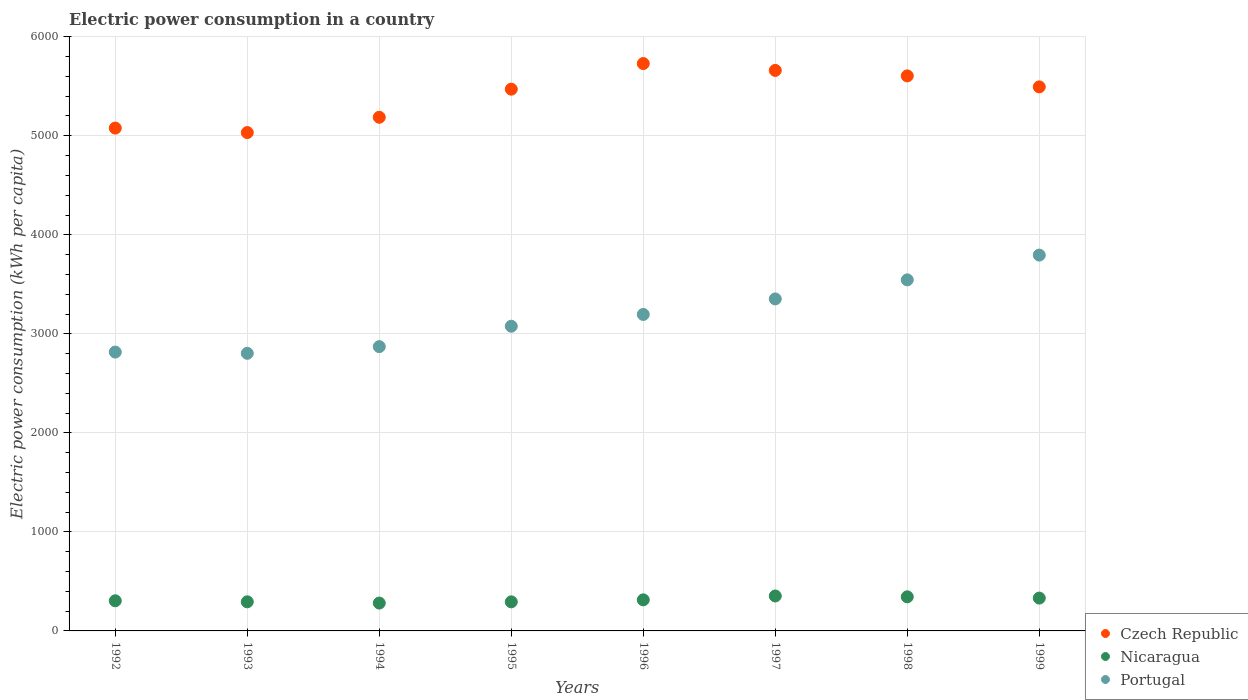How many different coloured dotlines are there?
Provide a succinct answer. 3. What is the electric power consumption in in Portugal in 1997?
Make the answer very short. 3352.47. Across all years, what is the maximum electric power consumption in in Portugal?
Your answer should be very brief. 3795.23. Across all years, what is the minimum electric power consumption in in Nicaragua?
Offer a terse response. 281.15. In which year was the electric power consumption in in Nicaragua maximum?
Your answer should be very brief. 1997. What is the total electric power consumption in in Nicaragua in the graph?
Make the answer very short. 2515.47. What is the difference between the electric power consumption in in Portugal in 1993 and that in 1994?
Your response must be concise. -67.63. What is the difference between the electric power consumption in in Nicaragua in 1998 and the electric power consumption in in Portugal in 1995?
Keep it short and to the point. -2732.47. What is the average electric power consumption in in Portugal per year?
Offer a very short reply. 3181.92. In the year 1992, what is the difference between the electric power consumption in in Nicaragua and electric power consumption in in Portugal?
Offer a terse response. -2511.58. In how many years, is the electric power consumption in in Czech Republic greater than 2000 kWh per capita?
Your answer should be compact. 8. What is the ratio of the electric power consumption in in Czech Republic in 1995 to that in 1999?
Offer a very short reply. 1. Is the difference between the electric power consumption in in Nicaragua in 1992 and 1997 greater than the difference between the electric power consumption in in Portugal in 1992 and 1997?
Your answer should be very brief. Yes. What is the difference between the highest and the second highest electric power consumption in in Portugal?
Your answer should be very brief. 250.22. What is the difference between the highest and the lowest electric power consumption in in Czech Republic?
Offer a very short reply. 696.98. Is the sum of the electric power consumption in in Portugal in 1995 and 1998 greater than the maximum electric power consumption in in Czech Republic across all years?
Ensure brevity in your answer.  Yes. Does the electric power consumption in in Portugal monotonically increase over the years?
Keep it short and to the point. No. Is the electric power consumption in in Portugal strictly greater than the electric power consumption in in Nicaragua over the years?
Your response must be concise. Yes. Is the electric power consumption in in Czech Republic strictly less than the electric power consumption in in Portugal over the years?
Make the answer very short. No. How many years are there in the graph?
Offer a terse response. 8. Does the graph contain any zero values?
Make the answer very short. No. How many legend labels are there?
Offer a terse response. 3. What is the title of the graph?
Make the answer very short. Electric power consumption in a country. What is the label or title of the X-axis?
Provide a succinct answer. Years. What is the label or title of the Y-axis?
Your answer should be very brief. Electric power consumption (kWh per capita). What is the Electric power consumption (kWh per capita) in Czech Republic in 1992?
Offer a terse response. 5077.66. What is the Electric power consumption (kWh per capita) in Nicaragua in 1992?
Your response must be concise. 304.3. What is the Electric power consumption (kWh per capita) in Portugal in 1992?
Your answer should be compact. 2815.88. What is the Electric power consumption (kWh per capita) in Czech Republic in 1993?
Your response must be concise. 5032.4. What is the Electric power consumption (kWh per capita) in Nicaragua in 1993?
Ensure brevity in your answer.  293.91. What is the Electric power consumption (kWh per capita) in Portugal in 1993?
Provide a short and direct response. 2803.2. What is the Electric power consumption (kWh per capita) of Czech Republic in 1994?
Your answer should be very brief. 5186.97. What is the Electric power consumption (kWh per capita) of Nicaragua in 1994?
Offer a very short reply. 281.15. What is the Electric power consumption (kWh per capita) in Portugal in 1994?
Offer a terse response. 2870.83. What is the Electric power consumption (kWh per capita) in Czech Republic in 1995?
Provide a short and direct response. 5470.67. What is the Electric power consumption (kWh per capita) in Nicaragua in 1995?
Give a very brief answer. 293.57. What is the Electric power consumption (kWh per capita) in Portugal in 1995?
Ensure brevity in your answer.  3076.85. What is the Electric power consumption (kWh per capita) of Czech Republic in 1996?
Keep it short and to the point. 5729.39. What is the Electric power consumption (kWh per capita) in Nicaragua in 1996?
Your answer should be compact. 313.78. What is the Electric power consumption (kWh per capita) of Portugal in 1996?
Your answer should be compact. 3195.86. What is the Electric power consumption (kWh per capita) of Czech Republic in 1997?
Offer a terse response. 5660.06. What is the Electric power consumption (kWh per capita) in Nicaragua in 1997?
Give a very brief answer. 352.86. What is the Electric power consumption (kWh per capita) in Portugal in 1997?
Ensure brevity in your answer.  3352.47. What is the Electric power consumption (kWh per capita) of Czech Republic in 1998?
Give a very brief answer. 5604.81. What is the Electric power consumption (kWh per capita) of Nicaragua in 1998?
Offer a very short reply. 344.38. What is the Electric power consumption (kWh per capita) in Portugal in 1998?
Make the answer very short. 3545.01. What is the Electric power consumption (kWh per capita) in Czech Republic in 1999?
Provide a succinct answer. 5493.85. What is the Electric power consumption (kWh per capita) of Nicaragua in 1999?
Your answer should be very brief. 331.54. What is the Electric power consumption (kWh per capita) of Portugal in 1999?
Your answer should be compact. 3795.23. Across all years, what is the maximum Electric power consumption (kWh per capita) in Czech Republic?
Your answer should be compact. 5729.39. Across all years, what is the maximum Electric power consumption (kWh per capita) in Nicaragua?
Keep it short and to the point. 352.86. Across all years, what is the maximum Electric power consumption (kWh per capita) of Portugal?
Your answer should be compact. 3795.23. Across all years, what is the minimum Electric power consumption (kWh per capita) of Czech Republic?
Keep it short and to the point. 5032.4. Across all years, what is the minimum Electric power consumption (kWh per capita) of Nicaragua?
Give a very brief answer. 281.15. Across all years, what is the minimum Electric power consumption (kWh per capita) in Portugal?
Your answer should be compact. 2803.2. What is the total Electric power consumption (kWh per capita) of Czech Republic in the graph?
Your answer should be very brief. 4.33e+04. What is the total Electric power consumption (kWh per capita) in Nicaragua in the graph?
Offer a terse response. 2515.47. What is the total Electric power consumption (kWh per capita) in Portugal in the graph?
Make the answer very short. 2.55e+04. What is the difference between the Electric power consumption (kWh per capita) in Czech Republic in 1992 and that in 1993?
Provide a short and direct response. 45.26. What is the difference between the Electric power consumption (kWh per capita) of Nicaragua in 1992 and that in 1993?
Provide a short and direct response. 10.39. What is the difference between the Electric power consumption (kWh per capita) in Portugal in 1992 and that in 1993?
Provide a succinct answer. 12.67. What is the difference between the Electric power consumption (kWh per capita) of Czech Republic in 1992 and that in 1994?
Ensure brevity in your answer.  -109.31. What is the difference between the Electric power consumption (kWh per capita) of Nicaragua in 1992 and that in 1994?
Your answer should be very brief. 23.15. What is the difference between the Electric power consumption (kWh per capita) of Portugal in 1992 and that in 1994?
Your answer should be compact. -54.96. What is the difference between the Electric power consumption (kWh per capita) of Czech Republic in 1992 and that in 1995?
Provide a succinct answer. -393.01. What is the difference between the Electric power consumption (kWh per capita) of Nicaragua in 1992 and that in 1995?
Offer a terse response. 10.73. What is the difference between the Electric power consumption (kWh per capita) in Portugal in 1992 and that in 1995?
Keep it short and to the point. -260.97. What is the difference between the Electric power consumption (kWh per capita) of Czech Republic in 1992 and that in 1996?
Give a very brief answer. -651.73. What is the difference between the Electric power consumption (kWh per capita) in Nicaragua in 1992 and that in 1996?
Offer a terse response. -9.48. What is the difference between the Electric power consumption (kWh per capita) in Portugal in 1992 and that in 1996?
Offer a terse response. -379.99. What is the difference between the Electric power consumption (kWh per capita) of Czech Republic in 1992 and that in 1997?
Make the answer very short. -582.4. What is the difference between the Electric power consumption (kWh per capita) of Nicaragua in 1992 and that in 1997?
Keep it short and to the point. -48.56. What is the difference between the Electric power consumption (kWh per capita) in Portugal in 1992 and that in 1997?
Give a very brief answer. -536.59. What is the difference between the Electric power consumption (kWh per capita) of Czech Republic in 1992 and that in 1998?
Offer a very short reply. -527.15. What is the difference between the Electric power consumption (kWh per capita) in Nicaragua in 1992 and that in 1998?
Ensure brevity in your answer.  -40.08. What is the difference between the Electric power consumption (kWh per capita) in Portugal in 1992 and that in 1998?
Provide a short and direct response. -729.13. What is the difference between the Electric power consumption (kWh per capita) of Czech Republic in 1992 and that in 1999?
Make the answer very short. -416.19. What is the difference between the Electric power consumption (kWh per capita) of Nicaragua in 1992 and that in 1999?
Your answer should be very brief. -27.24. What is the difference between the Electric power consumption (kWh per capita) of Portugal in 1992 and that in 1999?
Offer a terse response. -979.35. What is the difference between the Electric power consumption (kWh per capita) of Czech Republic in 1993 and that in 1994?
Provide a short and direct response. -154.57. What is the difference between the Electric power consumption (kWh per capita) in Nicaragua in 1993 and that in 1994?
Ensure brevity in your answer.  12.76. What is the difference between the Electric power consumption (kWh per capita) in Portugal in 1993 and that in 1994?
Your answer should be compact. -67.63. What is the difference between the Electric power consumption (kWh per capita) in Czech Republic in 1993 and that in 1995?
Your answer should be compact. -438.27. What is the difference between the Electric power consumption (kWh per capita) of Nicaragua in 1993 and that in 1995?
Your answer should be very brief. 0.34. What is the difference between the Electric power consumption (kWh per capita) in Portugal in 1993 and that in 1995?
Your answer should be very brief. -273.64. What is the difference between the Electric power consumption (kWh per capita) in Czech Republic in 1993 and that in 1996?
Offer a very short reply. -696.98. What is the difference between the Electric power consumption (kWh per capita) of Nicaragua in 1993 and that in 1996?
Offer a terse response. -19.87. What is the difference between the Electric power consumption (kWh per capita) in Portugal in 1993 and that in 1996?
Provide a short and direct response. -392.66. What is the difference between the Electric power consumption (kWh per capita) of Czech Republic in 1993 and that in 1997?
Offer a very short reply. -627.66. What is the difference between the Electric power consumption (kWh per capita) in Nicaragua in 1993 and that in 1997?
Give a very brief answer. -58.95. What is the difference between the Electric power consumption (kWh per capita) in Portugal in 1993 and that in 1997?
Your answer should be compact. -549.26. What is the difference between the Electric power consumption (kWh per capita) in Czech Republic in 1993 and that in 1998?
Provide a short and direct response. -572.41. What is the difference between the Electric power consumption (kWh per capita) of Nicaragua in 1993 and that in 1998?
Keep it short and to the point. -50.47. What is the difference between the Electric power consumption (kWh per capita) of Portugal in 1993 and that in 1998?
Ensure brevity in your answer.  -741.81. What is the difference between the Electric power consumption (kWh per capita) in Czech Republic in 1993 and that in 1999?
Make the answer very short. -461.45. What is the difference between the Electric power consumption (kWh per capita) of Nicaragua in 1993 and that in 1999?
Provide a succinct answer. -37.63. What is the difference between the Electric power consumption (kWh per capita) of Portugal in 1993 and that in 1999?
Your answer should be compact. -992.03. What is the difference between the Electric power consumption (kWh per capita) in Czech Republic in 1994 and that in 1995?
Offer a terse response. -283.7. What is the difference between the Electric power consumption (kWh per capita) in Nicaragua in 1994 and that in 1995?
Make the answer very short. -12.42. What is the difference between the Electric power consumption (kWh per capita) of Portugal in 1994 and that in 1995?
Your answer should be compact. -206.01. What is the difference between the Electric power consumption (kWh per capita) of Czech Republic in 1994 and that in 1996?
Keep it short and to the point. -542.42. What is the difference between the Electric power consumption (kWh per capita) in Nicaragua in 1994 and that in 1996?
Provide a short and direct response. -32.63. What is the difference between the Electric power consumption (kWh per capita) of Portugal in 1994 and that in 1996?
Your response must be concise. -325.03. What is the difference between the Electric power consumption (kWh per capita) of Czech Republic in 1994 and that in 1997?
Offer a terse response. -473.09. What is the difference between the Electric power consumption (kWh per capita) of Nicaragua in 1994 and that in 1997?
Offer a terse response. -71.71. What is the difference between the Electric power consumption (kWh per capita) in Portugal in 1994 and that in 1997?
Ensure brevity in your answer.  -481.63. What is the difference between the Electric power consumption (kWh per capita) of Czech Republic in 1994 and that in 1998?
Keep it short and to the point. -417.84. What is the difference between the Electric power consumption (kWh per capita) of Nicaragua in 1994 and that in 1998?
Your answer should be compact. -63.23. What is the difference between the Electric power consumption (kWh per capita) in Portugal in 1994 and that in 1998?
Your answer should be very brief. -674.18. What is the difference between the Electric power consumption (kWh per capita) in Czech Republic in 1994 and that in 1999?
Provide a succinct answer. -306.88. What is the difference between the Electric power consumption (kWh per capita) of Nicaragua in 1994 and that in 1999?
Make the answer very short. -50.39. What is the difference between the Electric power consumption (kWh per capita) in Portugal in 1994 and that in 1999?
Make the answer very short. -924.4. What is the difference between the Electric power consumption (kWh per capita) in Czech Republic in 1995 and that in 1996?
Your answer should be compact. -258.72. What is the difference between the Electric power consumption (kWh per capita) in Nicaragua in 1995 and that in 1996?
Your answer should be very brief. -20.21. What is the difference between the Electric power consumption (kWh per capita) of Portugal in 1995 and that in 1996?
Your answer should be very brief. -119.02. What is the difference between the Electric power consumption (kWh per capita) of Czech Republic in 1995 and that in 1997?
Give a very brief answer. -189.39. What is the difference between the Electric power consumption (kWh per capita) of Nicaragua in 1995 and that in 1997?
Provide a short and direct response. -59.29. What is the difference between the Electric power consumption (kWh per capita) of Portugal in 1995 and that in 1997?
Ensure brevity in your answer.  -275.62. What is the difference between the Electric power consumption (kWh per capita) in Czech Republic in 1995 and that in 1998?
Give a very brief answer. -134.14. What is the difference between the Electric power consumption (kWh per capita) in Nicaragua in 1995 and that in 1998?
Provide a short and direct response. -50.81. What is the difference between the Electric power consumption (kWh per capita) of Portugal in 1995 and that in 1998?
Make the answer very short. -468.16. What is the difference between the Electric power consumption (kWh per capita) of Czech Republic in 1995 and that in 1999?
Provide a short and direct response. -23.18. What is the difference between the Electric power consumption (kWh per capita) in Nicaragua in 1995 and that in 1999?
Your response must be concise. -37.97. What is the difference between the Electric power consumption (kWh per capita) of Portugal in 1995 and that in 1999?
Keep it short and to the point. -718.38. What is the difference between the Electric power consumption (kWh per capita) of Czech Republic in 1996 and that in 1997?
Give a very brief answer. 69.33. What is the difference between the Electric power consumption (kWh per capita) of Nicaragua in 1996 and that in 1997?
Your response must be concise. -39.08. What is the difference between the Electric power consumption (kWh per capita) of Portugal in 1996 and that in 1997?
Keep it short and to the point. -156.6. What is the difference between the Electric power consumption (kWh per capita) in Czech Republic in 1996 and that in 1998?
Keep it short and to the point. 124.58. What is the difference between the Electric power consumption (kWh per capita) in Nicaragua in 1996 and that in 1998?
Your answer should be very brief. -30.6. What is the difference between the Electric power consumption (kWh per capita) of Portugal in 1996 and that in 1998?
Keep it short and to the point. -349.15. What is the difference between the Electric power consumption (kWh per capita) in Czech Republic in 1996 and that in 1999?
Give a very brief answer. 235.53. What is the difference between the Electric power consumption (kWh per capita) in Nicaragua in 1996 and that in 1999?
Make the answer very short. -17.76. What is the difference between the Electric power consumption (kWh per capita) of Portugal in 1996 and that in 1999?
Offer a very short reply. -599.37. What is the difference between the Electric power consumption (kWh per capita) of Czech Republic in 1997 and that in 1998?
Offer a very short reply. 55.25. What is the difference between the Electric power consumption (kWh per capita) in Nicaragua in 1997 and that in 1998?
Ensure brevity in your answer.  8.48. What is the difference between the Electric power consumption (kWh per capita) in Portugal in 1997 and that in 1998?
Give a very brief answer. -192.54. What is the difference between the Electric power consumption (kWh per capita) of Czech Republic in 1997 and that in 1999?
Your answer should be very brief. 166.21. What is the difference between the Electric power consumption (kWh per capita) in Nicaragua in 1997 and that in 1999?
Ensure brevity in your answer.  21.32. What is the difference between the Electric power consumption (kWh per capita) in Portugal in 1997 and that in 1999?
Your answer should be very brief. -442.76. What is the difference between the Electric power consumption (kWh per capita) in Czech Republic in 1998 and that in 1999?
Ensure brevity in your answer.  110.96. What is the difference between the Electric power consumption (kWh per capita) of Nicaragua in 1998 and that in 1999?
Offer a terse response. 12.84. What is the difference between the Electric power consumption (kWh per capita) of Portugal in 1998 and that in 1999?
Keep it short and to the point. -250.22. What is the difference between the Electric power consumption (kWh per capita) in Czech Republic in 1992 and the Electric power consumption (kWh per capita) in Nicaragua in 1993?
Provide a short and direct response. 4783.75. What is the difference between the Electric power consumption (kWh per capita) of Czech Republic in 1992 and the Electric power consumption (kWh per capita) of Portugal in 1993?
Ensure brevity in your answer.  2274.46. What is the difference between the Electric power consumption (kWh per capita) of Nicaragua in 1992 and the Electric power consumption (kWh per capita) of Portugal in 1993?
Provide a short and direct response. -2498.9. What is the difference between the Electric power consumption (kWh per capita) of Czech Republic in 1992 and the Electric power consumption (kWh per capita) of Nicaragua in 1994?
Your answer should be very brief. 4796.51. What is the difference between the Electric power consumption (kWh per capita) in Czech Republic in 1992 and the Electric power consumption (kWh per capita) in Portugal in 1994?
Provide a succinct answer. 2206.83. What is the difference between the Electric power consumption (kWh per capita) in Nicaragua in 1992 and the Electric power consumption (kWh per capita) in Portugal in 1994?
Your response must be concise. -2566.53. What is the difference between the Electric power consumption (kWh per capita) of Czech Republic in 1992 and the Electric power consumption (kWh per capita) of Nicaragua in 1995?
Offer a very short reply. 4784.09. What is the difference between the Electric power consumption (kWh per capita) in Czech Republic in 1992 and the Electric power consumption (kWh per capita) in Portugal in 1995?
Offer a very short reply. 2000.81. What is the difference between the Electric power consumption (kWh per capita) in Nicaragua in 1992 and the Electric power consumption (kWh per capita) in Portugal in 1995?
Provide a succinct answer. -2772.55. What is the difference between the Electric power consumption (kWh per capita) in Czech Republic in 1992 and the Electric power consumption (kWh per capita) in Nicaragua in 1996?
Your response must be concise. 4763.88. What is the difference between the Electric power consumption (kWh per capita) in Czech Republic in 1992 and the Electric power consumption (kWh per capita) in Portugal in 1996?
Provide a short and direct response. 1881.8. What is the difference between the Electric power consumption (kWh per capita) in Nicaragua in 1992 and the Electric power consumption (kWh per capita) in Portugal in 1996?
Provide a short and direct response. -2891.57. What is the difference between the Electric power consumption (kWh per capita) of Czech Republic in 1992 and the Electric power consumption (kWh per capita) of Nicaragua in 1997?
Provide a succinct answer. 4724.8. What is the difference between the Electric power consumption (kWh per capita) of Czech Republic in 1992 and the Electric power consumption (kWh per capita) of Portugal in 1997?
Offer a very short reply. 1725.19. What is the difference between the Electric power consumption (kWh per capita) of Nicaragua in 1992 and the Electric power consumption (kWh per capita) of Portugal in 1997?
Offer a terse response. -3048.17. What is the difference between the Electric power consumption (kWh per capita) in Czech Republic in 1992 and the Electric power consumption (kWh per capita) in Nicaragua in 1998?
Give a very brief answer. 4733.28. What is the difference between the Electric power consumption (kWh per capita) of Czech Republic in 1992 and the Electric power consumption (kWh per capita) of Portugal in 1998?
Offer a terse response. 1532.65. What is the difference between the Electric power consumption (kWh per capita) in Nicaragua in 1992 and the Electric power consumption (kWh per capita) in Portugal in 1998?
Your answer should be very brief. -3240.71. What is the difference between the Electric power consumption (kWh per capita) in Czech Republic in 1992 and the Electric power consumption (kWh per capita) in Nicaragua in 1999?
Your answer should be very brief. 4746.12. What is the difference between the Electric power consumption (kWh per capita) of Czech Republic in 1992 and the Electric power consumption (kWh per capita) of Portugal in 1999?
Make the answer very short. 1282.43. What is the difference between the Electric power consumption (kWh per capita) of Nicaragua in 1992 and the Electric power consumption (kWh per capita) of Portugal in 1999?
Make the answer very short. -3490.93. What is the difference between the Electric power consumption (kWh per capita) of Czech Republic in 1993 and the Electric power consumption (kWh per capita) of Nicaragua in 1994?
Your answer should be compact. 4751.25. What is the difference between the Electric power consumption (kWh per capita) in Czech Republic in 1993 and the Electric power consumption (kWh per capita) in Portugal in 1994?
Provide a short and direct response. 2161.57. What is the difference between the Electric power consumption (kWh per capita) in Nicaragua in 1993 and the Electric power consumption (kWh per capita) in Portugal in 1994?
Ensure brevity in your answer.  -2576.93. What is the difference between the Electric power consumption (kWh per capita) in Czech Republic in 1993 and the Electric power consumption (kWh per capita) in Nicaragua in 1995?
Make the answer very short. 4738.84. What is the difference between the Electric power consumption (kWh per capita) in Czech Republic in 1993 and the Electric power consumption (kWh per capita) in Portugal in 1995?
Give a very brief answer. 1955.56. What is the difference between the Electric power consumption (kWh per capita) in Nicaragua in 1993 and the Electric power consumption (kWh per capita) in Portugal in 1995?
Your response must be concise. -2782.94. What is the difference between the Electric power consumption (kWh per capita) of Czech Republic in 1993 and the Electric power consumption (kWh per capita) of Nicaragua in 1996?
Ensure brevity in your answer.  4718.63. What is the difference between the Electric power consumption (kWh per capita) of Czech Republic in 1993 and the Electric power consumption (kWh per capita) of Portugal in 1996?
Offer a very short reply. 1836.54. What is the difference between the Electric power consumption (kWh per capita) of Nicaragua in 1993 and the Electric power consumption (kWh per capita) of Portugal in 1996?
Keep it short and to the point. -2901.96. What is the difference between the Electric power consumption (kWh per capita) of Czech Republic in 1993 and the Electric power consumption (kWh per capita) of Nicaragua in 1997?
Offer a very short reply. 4679.55. What is the difference between the Electric power consumption (kWh per capita) of Czech Republic in 1993 and the Electric power consumption (kWh per capita) of Portugal in 1997?
Provide a succinct answer. 1679.94. What is the difference between the Electric power consumption (kWh per capita) of Nicaragua in 1993 and the Electric power consumption (kWh per capita) of Portugal in 1997?
Give a very brief answer. -3058.56. What is the difference between the Electric power consumption (kWh per capita) in Czech Republic in 1993 and the Electric power consumption (kWh per capita) in Nicaragua in 1998?
Give a very brief answer. 4688.02. What is the difference between the Electric power consumption (kWh per capita) in Czech Republic in 1993 and the Electric power consumption (kWh per capita) in Portugal in 1998?
Your response must be concise. 1487.39. What is the difference between the Electric power consumption (kWh per capita) in Nicaragua in 1993 and the Electric power consumption (kWh per capita) in Portugal in 1998?
Make the answer very short. -3251.1. What is the difference between the Electric power consumption (kWh per capita) of Czech Republic in 1993 and the Electric power consumption (kWh per capita) of Nicaragua in 1999?
Give a very brief answer. 4700.87. What is the difference between the Electric power consumption (kWh per capita) in Czech Republic in 1993 and the Electric power consumption (kWh per capita) in Portugal in 1999?
Provide a succinct answer. 1237.17. What is the difference between the Electric power consumption (kWh per capita) of Nicaragua in 1993 and the Electric power consumption (kWh per capita) of Portugal in 1999?
Ensure brevity in your answer.  -3501.32. What is the difference between the Electric power consumption (kWh per capita) in Czech Republic in 1994 and the Electric power consumption (kWh per capita) in Nicaragua in 1995?
Offer a very short reply. 4893.4. What is the difference between the Electric power consumption (kWh per capita) in Czech Republic in 1994 and the Electric power consumption (kWh per capita) in Portugal in 1995?
Your answer should be compact. 2110.12. What is the difference between the Electric power consumption (kWh per capita) of Nicaragua in 1994 and the Electric power consumption (kWh per capita) of Portugal in 1995?
Provide a succinct answer. -2795.7. What is the difference between the Electric power consumption (kWh per capita) in Czech Republic in 1994 and the Electric power consumption (kWh per capita) in Nicaragua in 1996?
Offer a very short reply. 4873.19. What is the difference between the Electric power consumption (kWh per capita) in Czech Republic in 1994 and the Electric power consumption (kWh per capita) in Portugal in 1996?
Your answer should be very brief. 1991.11. What is the difference between the Electric power consumption (kWh per capita) in Nicaragua in 1994 and the Electric power consumption (kWh per capita) in Portugal in 1996?
Provide a short and direct response. -2914.71. What is the difference between the Electric power consumption (kWh per capita) in Czech Republic in 1994 and the Electric power consumption (kWh per capita) in Nicaragua in 1997?
Your response must be concise. 4834.11. What is the difference between the Electric power consumption (kWh per capita) of Czech Republic in 1994 and the Electric power consumption (kWh per capita) of Portugal in 1997?
Your response must be concise. 1834.5. What is the difference between the Electric power consumption (kWh per capita) of Nicaragua in 1994 and the Electric power consumption (kWh per capita) of Portugal in 1997?
Offer a terse response. -3071.32. What is the difference between the Electric power consumption (kWh per capita) of Czech Republic in 1994 and the Electric power consumption (kWh per capita) of Nicaragua in 1998?
Give a very brief answer. 4842.59. What is the difference between the Electric power consumption (kWh per capita) of Czech Republic in 1994 and the Electric power consumption (kWh per capita) of Portugal in 1998?
Offer a very short reply. 1641.96. What is the difference between the Electric power consumption (kWh per capita) in Nicaragua in 1994 and the Electric power consumption (kWh per capita) in Portugal in 1998?
Offer a very short reply. -3263.86. What is the difference between the Electric power consumption (kWh per capita) of Czech Republic in 1994 and the Electric power consumption (kWh per capita) of Nicaragua in 1999?
Provide a short and direct response. 4855.43. What is the difference between the Electric power consumption (kWh per capita) of Czech Republic in 1994 and the Electric power consumption (kWh per capita) of Portugal in 1999?
Make the answer very short. 1391.74. What is the difference between the Electric power consumption (kWh per capita) of Nicaragua in 1994 and the Electric power consumption (kWh per capita) of Portugal in 1999?
Your answer should be compact. -3514.08. What is the difference between the Electric power consumption (kWh per capita) of Czech Republic in 1995 and the Electric power consumption (kWh per capita) of Nicaragua in 1996?
Give a very brief answer. 5156.89. What is the difference between the Electric power consumption (kWh per capita) of Czech Republic in 1995 and the Electric power consumption (kWh per capita) of Portugal in 1996?
Offer a very short reply. 2274.81. What is the difference between the Electric power consumption (kWh per capita) in Nicaragua in 1995 and the Electric power consumption (kWh per capita) in Portugal in 1996?
Give a very brief answer. -2902.3. What is the difference between the Electric power consumption (kWh per capita) in Czech Republic in 1995 and the Electric power consumption (kWh per capita) in Nicaragua in 1997?
Offer a very short reply. 5117.81. What is the difference between the Electric power consumption (kWh per capita) in Czech Republic in 1995 and the Electric power consumption (kWh per capita) in Portugal in 1997?
Give a very brief answer. 2118.2. What is the difference between the Electric power consumption (kWh per capita) in Nicaragua in 1995 and the Electric power consumption (kWh per capita) in Portugal in 1997?
Ensure brevity in your answer.  -3058.9. What is the difference between the Electric power consumption (kWh per capita) of Czech Republic in 1995 and the Electric power consumption (kWh per capita) of Nicaragua in 1998?
Ensure brevity in your answer.  5126.29. What is the difference between the Electric power consumption (kWh per capita) in Czech Republic in 1995 and the Electric power consumption (kWh per capita) in Portugal in 1998?
Ensure brevity in your answer.  1925.66. What is the difference between the Electric power consumption (kWh per capita) in Nicaragua in 1995 and the Electric power consumption (kWh per capita) in Portugal in 1998?
Your answer should be very brief. -3251.44. What is the difference between the Electric power consumption (kWh per capita) of Czech Republic in 1995 and the Electric power consumption (kWh per capita) of Nicaragua in 1999?
Offer a terse response. 5139.13. What is the difference between the Electric power consumption (kWh per capita) of Czech Republic in 1995 and the Electric power consumption (kWh per capita) of Portugal in 1999?
Offer a very short reply. 1675.44. What is the difference between the Electric power consumption (kWh per capita) in Nicaragua in 1995 and the Electric power consumption (kWh per capita) in Portugal in 1999?
Offer a terse response. -3501.66. What is the difference between the Electric power consumption (kWh per capita) in Czech Republic in 1996 and the Electric power consumption (kWh per capita) in Nicaragua in 1997?
Provide a succinct answer. 5376.53. What is the difference between the Electric power consumption (kWh per capita) in Czech Republic in 1996 and the Electric power consumption (kWh per capita) in Portugal in 1997?
Your answer should be very brief. 2376.92. What is the difference between the Electric power consumption (kWh per capita) in Nicaragua in 1996 and the Electric power consumption (kWh per capita) in Portugal in 1997?
Make the answer very short. -3038.69. What is the difference between the Electric power consumption (kWh per capita) of Czech Republic in 1996 and the Electric power consumption (kWh per capita) of Nicaragua in 1998?
Your answer should be very brief. 5385.01. What is the difference between the Electric power consumption (kWh per capita) in Czech Republic in 1996 and the Electric power consumption (kWh per capita) in Portugal in 1998?
Your answer should be very brief. 2184.38. What is the difference between the Electric power consumption (kWh per capita) of Nicaragua in 1996 and the Electric power consumption (kWh per capita) of Portugal in 1998?
Give a very brief answer. -3231.23. What is the difference between the Electric power consumption (kWh per capita) of Czech Republic in 1996 and the Electric power consumption (kWh per capita) of Nicaragua in 1999?
Provide a succinct answer. 5397.85. What is the difference between the Electric power consumption (kWh per capita) of Czech Republic in 1996 and the Electric power consumption (kWh per capita) of Portugal in 1999?
Provide a succinct answer. 1934.16. What is the difference between the Electric power consumption (kWh per capita) in Nicaragua in 1996 and the Electric power consumption (kWh per capita) in Portugal in 1999?
Your answer should be very brief. -3481.45. What is the difference between the Electric power consumption (kWh per capita) of Czech Republic in 1997 and the Electric power consumption (kWh per capita) of Nicaragua in 1998?
Provide a short and direct response. 5315.68. What is the difference between the Electric power consumption (kWh per capita) of Czech Republic in 1997 and the Electric power consumption (kWh per capita) of Portugal in 1998?
Give a very brief answer. 2115.05. What is the difference between the Electric power consumption (kWh per capita) of Nicaragua in 1997 and the Electric power consumption (kWh per capita) of Portugal in 1998?
Make the answer very short. -3192.15. What is the difference between the Electric power consumption (kWh per capita) of Czech Republic in 1997 and the Electric power consumption (kWh per capita) of Nicaragua in 1999?
Offer a terse response. 5328.52. What is the difference between the Electric power consumption (kWh per capita) of Czech Republic in 1997 and the Electric power consumption (kWh per capita) of Portugal in 1999?
Your answer should be very brief. 1864.83. What is the difference between the Electric power consumption (kWh per capita) in Nicaragua in 1997 and the Electric power consumption (kWh per capita) in Portugal in 1999?
Provide a short and direct response. -3442.37. What is the difference between the Electric power consumption (kWh per capita) in Czech Republic in 1998 and the Electric power consumption (kWh per capita) in Nicaragua in 1999?
Provide a short and direct response. 5273.27. What is the difference between the Electric power consumption (kWh per capita) in Czech Republic in 1998 and the Electric power consumption (kWh per capita) in Portugal in 1999?
Your response must be concise. 1809.58. What is the difference between the Electric power consumption (kWh per capita) of Nicaragua in 1998 and the Electric power consumption (kWh per capita) of Portugal in 1999?
Your answer should be compact. -3450.85. What is the average Electric power consumption (kWh per capita) of Czech Republic per year?
Keep it short and to the point. 5406.98. What is the average Electric power consumption (kWh per capita) in Nicaragua per year?
Make the answer very short. 314.43. What is the average Electric power consumption (kWh per capita) in Portugal per year?
Provide a short and direct response. 3181.92. In the year 1992, what is the difference between the Electric power consumption (kWh per capita) in Czech Republic and Electric power consumption (kWh per capita) in Nicaragua?
Give a very brief answer. 4773.36. In the year 1992, what is the difference between the Electric power consumption (kWh per capita) of Czech Republic and Electric power consumption (kWh per capita) of Portugal?
Your answer should be very brief. 2261.78. In the year 1992, what is the difference between the Electric power consumption (kWh per capita) of Nicaragua and Electric power consumption (kWh per capita) of Portugal?
Offer a terse response. -2511.58. In the year 1993, what is the difference between the Electric power consumption (kWh per capita) of Czech Republic and Electric power consumption (kWh per capita) of Nicaragua?
Keep it short and to the point. 4738.5. In the year 1993, what is the difference between the Electric power consumption (kWh per capita) in Czech Republic and Electric power consumption (kWh per capita) in Portugal?
Ensure brevity in your answer.  2229.2. In the year 1993, what is the difference between the Electric power consumption (kWh per capita) of Nicaragua and Electric power consumption (kWh per capita) of Portugal?
Make the answer very short. -2509.3. In the year 1994, what is the difference between the Electric power consumption (kWh per capita) of Czech Republic and Electric power consumption (kWh per capita) of Nicaragua?
Your response must be concise. 4905.82. In the year 1994, what is the difference between the Electric power consumption (kWh per capita) in Czech Republic and Electric power consumption (kWh per capita) in Portugal?
Keep it short and to the point. 2316.14. In the year 1994, what is the difference between the Electric power consumption (kWh per capita) of Nicaragua and Electric power consumption (kWh per capita) of Portugal?
Give a very brief answer. -2589.68. In the year 1995, what is the difference between the Electric power consumption (kWh per capita) of Czech Republic and Electric power consumption (kWh per capita) of Nicaragua?
Keep it short and to the point. 5177.1. In the year 1995, what is the difference between the Electric power consumption (kWh per capita) of Czech Republic and Electric power consumption (kWh per capita) of Portugal?
Your response must be concise. 2393.82. In the year 1995, what is the difference between the Electric power consumption (kWh per capita) of Nicaragua and Electric power consumption (kWh per capita) of Portugal?
Keep it short and to the point. -2783.28. In the year 1996, what is the difference between the Electric power consumption (kWh per capita) in Czech Republic and Electric power consumption (kWh per capita) in Nicaragua?
Offer a terse response. 5415.61. In the year 1996, what is the difference between the Electric power consumption (kWh per capita) in Czech Republic and Electric power consumption (kWh per capita) in Portugal?
Offer a terse response. 2533.52. In the year 1996, what is the difference between the Electric power consumption (kWh per capita) in Nicaragua and Electric power consumption (kWh per capita) in Portugal?
Provide a short and direct response. -2882.09. In the year 1997, what is the difference between the Electric power consumption (kWh per capita) of Czech Republic and Electric power consumption (kWh per capita) of Nicaragua?
Provide a short and direct response. 5307.2. In the year 1997, what is the difference between the Electric power consumption (kWh per capita) in Czech Republic and Electric power consumption (kWh per capita) in Portugal?
Your answer should be very brief. 2307.59. In the year 1997, what is the difference between the Electric power consumption (kWh per capita) of Nicaragua and Electric power consumption (kWh per capita) of Portugal?
Provide a short and direct response. -2999.61. In the year 1998, what is the difference between the Electric power consumption (kWh per capita) in Czech Republic and Electric power consumption (kWh per capita) in Nicaragua?
Your answer should be very brief. 5260.43. In the year 1998, what is the difference between the Electric power consumption (kWh per capita) of Czech Republic and Electric power consumption (kWh per capita) of Portugal?
Provide a succinct answer. 2059.8. In the year 1998, what is the difference between the Electric power consumption (kWh per capita) of Nicaragua and Electric power consumption (kWh per capita) of Portugal?
Your answer should be compact. -3200.63. In the year 1999, what is the difference between the Electric power consumption (kWh per capita) in Czech Republic and Electric power consumption (kWh per capita) in Nicaragua?
Provide a short and direct response. 5162.31. In the year 1999, what is the difference between the Electric power consumption (kWh per capita) in Czech Republic and Electric power consumption (kWh per capita) in Portugal?
Keep it short and to the point. 1698.62. In the year 1999, what is the difference between the Electric power consumption (kWh per capita) in Nicaragua and Electric power consumption (kWh per capita) in Portugal?
Ensure brevity in your answer.  -3463.69. What is the ratio of the Electric power consumption (kWh per capita) in Czech Republic in 1992 to that in 1993?
Offer a very short reply. 1.01. What is the ratio of the Electric power consumption (kWh per capita) of Nicaragua in 1992 to that in 1993?
Give a very brief answer. 1.04. What is the ratio of the Electric power consumption (kWh per capita) in Czech Republic in 1992 to that in 1994?
Your answer should be compact. 0.98. What is the ratio of the Electric power consumption (kWh per capita) in Nicaragua in 1992 to that in 1994?
Offer a terse response. 1.08. What is the ratio of the Electric power consumption (kWh per capita) of Portugal in 1992 to that in 1994?
Offer a very short reply. 0.98. What is the ratio of the Electric power consumption (kWh per capita) of Czech Republic in 1992 to that in 1995?
Your answer should be compact. 0.93. What is the ratio of the Electric power consumption (kWh per capita) in Nicaragua in 1992 to that in 1995?
Ensure brevity in your answer.  1.04. What is the ratio of the Electric power consumption (kWh per capita) of Portugal in 1992 to that in 1995?
Your answer should be compact. 0.92. What is the ratio of the Electric power consumption (kWh per capita) in Czech Republic in 1992 to that in 1996?
Your response must be concise. 0.89. What is the ratio of the Electric power consumption (kWh per capita) of Nicaragua in 1992 to that in 1996?
Your answer should be compact. 0.97. What is the ratio of the Electric power consumption (kWh per capita) of Portugal in 1992 to that in 1996?
Keep it short and to the point. 0.88. What is the ratio of the Electric power consumption (kWh per capita) in Czech Republic in 1992 to that in 1997?
Make the answer very short. 0.9. What is the ratio of the Electric power consumption (kWh per capita) in Nicaragua in 1992 to that in 1997?
Keep it short and to the point. 0.86. What is the ratio of the Electric power consumption (kWh per capita) of Portugal in 1992 to that in 1997?
Keep it short and to the point. 0.84. What is the ratio of the Electric power consumption (kWh per capita) of Czech Republic in 1992 to that in 1998?
Offer a terse response. 0.91. What is the ratio of the Electric power consumption (kWh per capita) in Nicaragua in 1992 to that in 1998?
Your answer should be compact. 0.88. What is the ratio of the Electric power consumption (kWh per capita) of Portugal in 1992 to that in 1998?
Make the answer very short. 0.79. What is the ratio of the Electric power consumption (kWh per capita) in Czech Republic in 1992 to that in 1999?
Offer a terse response. 0.92. What is the ratio of the Electric power consumption (kWh per capita) of Nicaragua in 1992 to that in 1999?
Offer a very short reply. 0.92. What is the ratio of the Electric power consumption (kWh per capita) of Portugal in 1992 to that in 1999?
Ensure brevity in your answer.  0.74. What is the ratio of the Electric power consumption (kWh per capita) in Czech Republic in 1993 to that in 1994?
Your response must be concise. 0.97. What is the ratio of the Electric power consumption (kWh per capita) of Nicaragua in 1993 to that in 1994?
Make the answer very short. 1.05. What is the ratio of the Electric power consumption (kWh per capita) of Portugal in 1993 to that in 1994?
Your answer should be very brief. 0.98. What is the ratio of the Electric power consumption (kWh per capita) of Czech Republic in 1993 to that in 1995?
Provide a short and direct response. 0.92. What is the ratio of the Electric power consumption (kWh per capita) of Nicaragua in 1993 to that in 1995?
Your answer should be very brief. 1. What is the ratio of the Electric power consumption (kWh per capita) in Portugal in 1993 to that in 1995?
Provide a short and direct response. 0.91. What is the ratio of the Electric power consumption (kWh per capita) in Czech Republic in 1993 to that in 1996?
Your answer should be very brief. 0.88. What is the ratio of the Electric power consumption (kWh per capita) of Nicaragua in 1993 to that in 1996?
Provide a short and direct response. 0.94. What is the ratio of the Electric power consumption (kWh per capita) of Portugal in 1993 to that in 1996?
Keep it short and to the point. 0.88. What is the ratio of the Electric power consumption (kWh per capita) in Czech Republic in 1993 to that in 1997?
Keep it short and to the point. 0.89. What is the ratio of the Electric power consumption (kWh per capita) in Nicaragua in 1993 to that in 1997?
Ensure brevity in your answer.  0.83. What is the ratio of the Electric power consumption (kWh per capita) in Portugal in 1993 to that in 1997?
Offer a terse response. 0.84. What is the ratio of the Electric power consumption (kWh per capita) in Czech Republic in 1993 to that in 1998?
Offer a terse response. 0.9. What is the ratio of the Electric power consumption (kWh per capita) of Nicaragua in 1993 to that in 1998?
Keep it short and to the point. 0.85. What is the ratio of the Electric power consumption (kWh per capita) of Portugal in 1993 to that in 1998?
Keep it short and to the point. 0.79. What is the ratio of the Electric power consumption (kWh per capita) of Czech Republic in 1993 to that in 1999?
Offer a very short reply. 0.92. What is the ratio of the Electric power consumption (kWh per capita) of Nicaragua in 1993 to that in 1999?
Ensure brevity in your answer.  0.89. What is the ratio of the Electric power consumption (kWh per capita) of Portugal in 1993 to that in 1999?
Keep it short and to the point. 0.74. What is the ratio of the Electric power consumption (kWh per capita) in Czech Republic in 1994 to that in 1995?
Keep it short and to the point. 0.95. What is the ratio of the Electric power consumption (kWh per capita) in Nicaragua in 1994 to that in 1995?
Provide a short and direct response. 0.96. What is the ratio of the Electric power consumption (kWh per capita) in Portugal in 1994 to that in 1995?
Provide a succinct answer. 0.93. What is the ratio of the Electric power consumption (kWh per capita) in Czech Republic in 1994 to that in 1996?
Give a very brief answer. 0.91. What is the ratio of the Electric power consumption (kWh per capita) of Nicaragua in 1994 to that in 1996?
Provide a succinct answer. 0.9. What is the ratio of the Electric power consumption (kWh per capita) of Portugal in 1994 to that in 1996?
Your answer should be very brief. 0.9. What is the ratio of the Electric power consumption (kWh per capita) of Czech Republic in 1994 to that in 1997?
Offer a very short reply. 0.92. What is the ratio of the Electric power consumption (kWh per capita) of Nicaragua in 1994 to that in 1997?
Give a very brief answer. 0.8. What is the ratio of the Electric power consumption (kWh per capita) in Portugal in 1994 to that in 1997?
Your answer should be compact. 0.86. What is the ratio of the Electric power consumption (kWh per capita) of Czech Republic in 1994 to that in 1998?
Keep it short and to the point. 0.93. What is the ratio of the Electric power consumption (kWh per capita) in Nicaragua in 1994 to that in 1998?
Your response must be concise. 0.82. What is the ratio of the Electric power consumption (kWh per capita) of Portugal in 1994 to that in 1998?
Your answer should be very brief. 0.81. What is the ratio of the Electric power consumption (kWh per capita) in Czech Republic in 1994 to that in 1999?
Ensure brevity in your answer.  0.94. What is the ratio of the Electric power consumption (kWh per capita) in Nicaragua in 1994 to that in 1999?
Give a very brief answer. 0.85. What is the ratio of the Electric power consumption (kWh per capita) in Portugal in 1994 to that in 1999?
Provide a succinct answer. 0.76. What is the ratio of the Electric power consumption (kWh per capita) in Czech Republic in 1995 to that in 1996?
Make the answer very short. 0.95. What is the ratio of the Electric power consumption (kWh per capita) in Nicaragua in 1995 to that in 1996?
Keep it short and to the point. 0.94. What is the ratio of the Electric power consumption (kWh per capita) of Portugal in 1995 to that in 1996?
Give a very brief answer. 0.96. What is the ratio of the Electric power consumption (kWh per capita) in Czech Republic in 1995 to that in 1997?
Keep it short and to the point. 0.97. What is the ratio of the Electric power consumption (kWh per capita) of Nicaragua in 1995 to that in 1997?
Offer a very short reply. 0.83. What is the ratio of the Electric power consumption (kWh per capita) in Portugal in 1995 to that in 1997?
Provide a succinct answer. 0.92. What is the ratio of the Electric power consumption (kWh per capita) in Czech Republic in 1995 to that in 1998?
Your response must be concise. 0.98. What is the ratio of the Electric power consumption (kWh per capita) in Nicaragua in 1995 to that in 1998?
Your answer should be very brief. 0.85. What is the ratio of the Electric power consumption (kWh per capita) in Portugal in 1995 to that in 1998?
Your response must be concise. 0.87. What is the ratio of the Electric power consumption (kWh per capita) in Czech Republic in 1995 to that in 1999?
Your answer should be compact. 1. What is the ratio of the Electric power consumption (kWh per capita) of Nicaragua in 1995 to that in 1999?
Keep it short and to the point. 0.89. What is the ratio of the Electric power consumption (kWh per capita) of Portugal in 1995 to that in 1999?
Offer a very short reply. 0.81. What is the ratio of the Electric power consumption (kWh per capita) in Czech Republic in 1996 to that in 1997?
Provide a short and direct response. 1.01. What is the ratio of the Electric power consumption (kWh per capita) in Nicaragua in 1996 to that in 1997?
Give a very brief answer. 0.89. What is the ratio of the Electric power consumption (kWh per capita) of Portugal in 1996 to that in 1997?
Make the answer very short. 0.95. What is the ratio of the Electric power consumption (kWh per capita) in Czech Republic in 1996 to that in 1998?
Keep it short and to the point. 1.02. What is the ratio of the Electric power consumption (kWh per capita) of Nicaragua in 1996 to that in 1998?
Make the answer very short. 0.91. What is the ratio of the Electric power consumption (kWh per capita) in Portugal in 1996 to that in 1998?
Ensure brevity in your answer.  0.9. What is the ratio of the Electric power consumption (kWh per capita) in Czech Republic in 1996 to that in 1999?
Your response must be concise. 1.04. What is the ratio of the Electric power consumption (kWh per capita) of Nicaragua in 1996 to that in 1999?
Provide a short and direct response. 0.95. What is the ratio of the Electric power consumption (kWh per capita) of Portugal in 1996 to that in 1999?
Your response must be concise. 0.84. What is the ratio of the Electric power consumption (kWh per capita) in Czech Republic in 1997 to that in 1998?
Keep it short and to the point. 1.01. What is the ratio of the Electric power consumption (kWh per capita) of Nicaragua in 1997 to that in 1998?
Offer a terse response. 1.02. What is the ratio of the Electric power consumption (kWh per capita) of Portugal in 1997 to that in 1998?
Keep it short and to the point. 0.95. What is the ratio of the Electric power consumption (kWh per capita) in Czech Republic in 1997 to that in 1999?
Give a very brief answer. 1.03. What is the ratio of the Electric power consumption (kWh per capita) of Nicaragua in 1997 to that in 1999?
Offer a terse response. 1.06. What is the ratio of the Electric power consumption (kWh per capita) in Portugal in 1997 to that in 1999?
Offer a terse response. 0.88. What is the ratio of the Electric power consumption (kWh per capita) of Czech Republic in 1998 to that in 1999?
Your response must be concise. 1.02. What is the ratio of the Electric power consumption (kWh per capita) of Nicaragua in 1998 to that in 1999?
Provide a succinct answer. 1.04. What is the ratio of the Electric power consumption (kWh per capita) in Portugal in 1998 to that in 1999?
Make the answer very short. 0.93. What is the difference between the highest and the second highest Electric power consumption (kWh per capita) of Czech Republic?
Your answer should be very brief. 69.33. What is the difference between the highest and the second highest Electric power consumption (kWh per capita) in Nicaragua?
Provide a short and direct response. 8.48. What is the difference between the highest and the second highest Electric power consumption (kWh per capita) in Portugal?
Your answer should be compact. 250.22. What is the difference between the highest and the lowest Electric power consumption (kWh per capita) in Czech Republic?
Give a very brief answer. 696.98. What is the difference between the highest and the lowest Electric power consumption (kWh per capita) of Nicaragua?
Offer a terse response. 71.71. What is the difference between the highest and the lowest Electric power consumption (kWh per capita) of Portugal?
Offer a terse response. 992.03. 